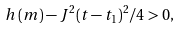Convert formula to latex. <formula><loc_0><loc_0><loc_500><loc_500>h \left ( m \right ) - J ^ { 2 } ( t - t _ { 1 } ) ^ { 2 } / 4 > 0 ,</formula> 